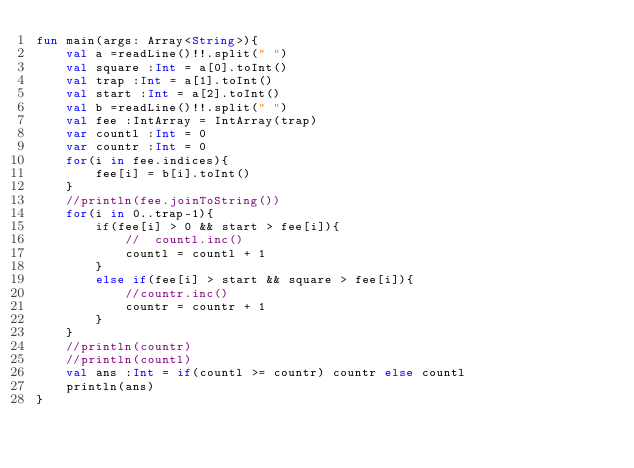<code> <loc_0><loc_0><loc_500><loc_500><_Kotlin_>fun main(args: Array<String>){
    val a =readLine()!!.split(" ")
    val square :Int = a[0].toInt()
    val trap :Int = a[1].toInt()
    val start :Int = a[2].toInt()
    val b =readLine()!!.split(" ")
    val fee :IntArray = IntArray(trap)
    var countl :Int = 0
    var countr :Int = 0
    for(i in fee.indices){
        fee[i] = b[i].toInt()
    }
    //println(fee.joinToString())
    for(i in 0..trap-1){
        if(fee[i] > 0 && start > fee[i]){
            //  countl.inc()
            countl = countl + 1
        }
        else if(fee[i] > start && square > fee[i]){
            //countr.inc()
            countr = countr + 1
        }
    }
    //println(countr)
    //println(countl)
    val ans :Int = if(countl >= countr) countr else countl
    println(ans)
}</code> 